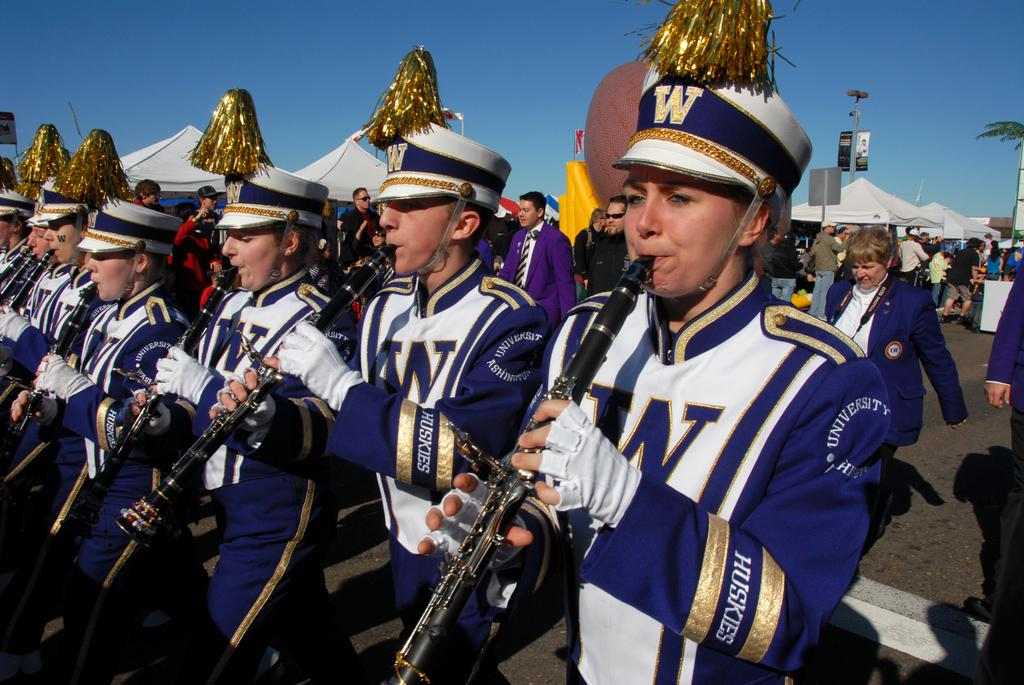What are the persons in the front of the image doing? The persons in the front of the image are playing a musical instrument. What are the persons in the center of the image doing? The persons in the center of the image are walking. What can be seen in the background of the image? In the background, there are tents and persons, as well as a tree. What type of lip can be seen on the ball in the image? There is no lip or ball present in the image. What industry is depicted in the background of the image? The image does not depict any industry; it features tents, persons, and a tree in the background. 